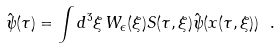Convert formula to latex. <formula><loc_0><loc_0><loc_500><loc_500>\hat { \psi } ( \tau ) = \int d ^ { 3 } \xi \, W _ { \epsilon } ( \xi ) S ( \tau , \xi ) \hat { \psi } ( x ( \tau , \xi ) ) \ .</formula> 